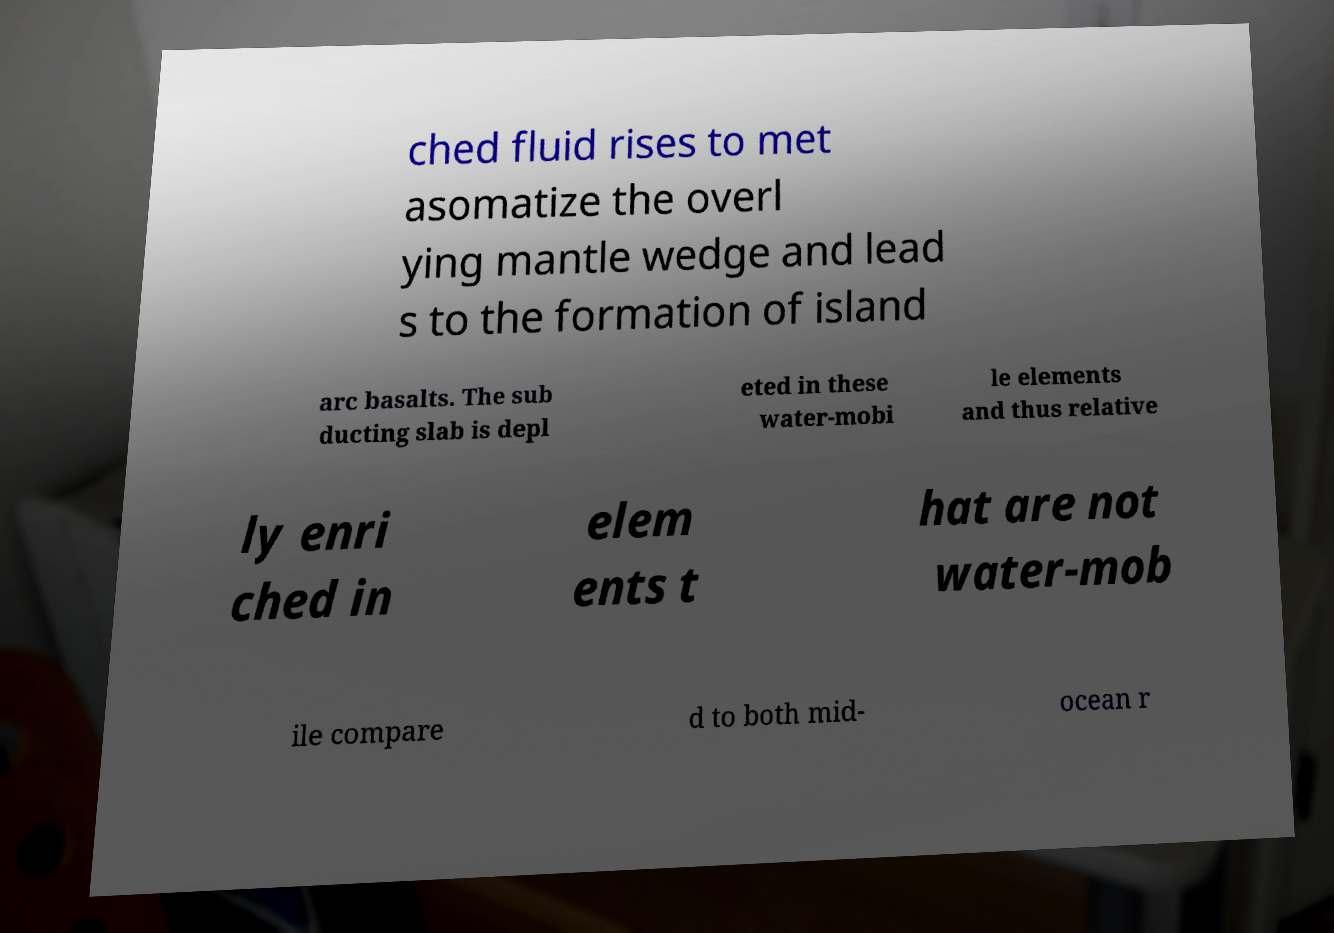I need the written content from this picture converted into text. Can you do that? ched fluid rises to met asomatize the overl ying mantle wedge and lead s to the formation of island arc basalts. The sub ducting slab is depl eted in these water-mobi le elements and thus relative ly enri ched in elem ents t hat are not water-mob ile compare d to both mid- ocean r 